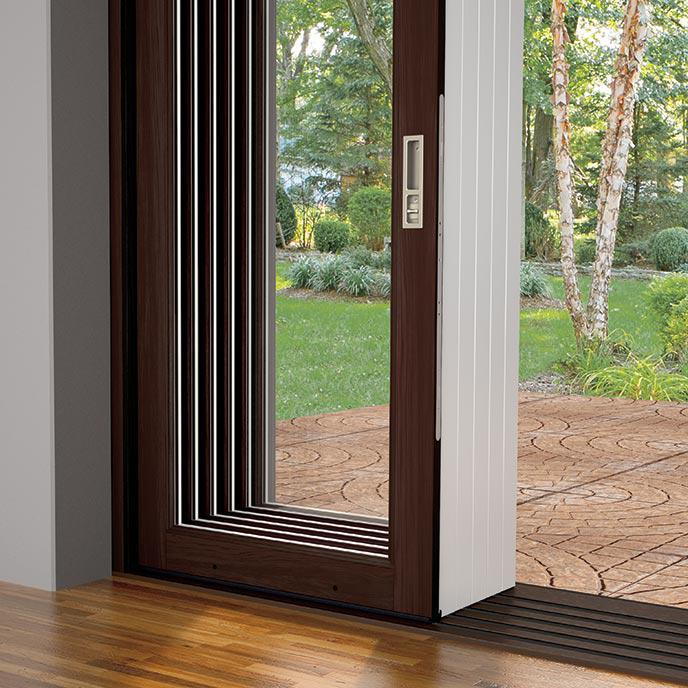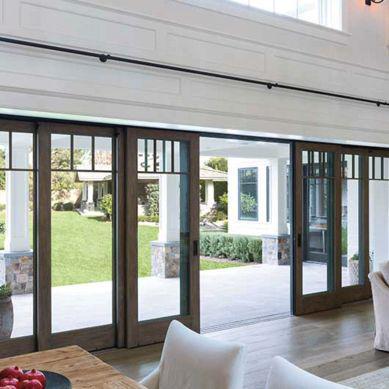The first image is the image on the left, the second image is the image on the right. For the images displayed, is the sentence "In at least one image there is an open white and glass panel door that shows chairs behind it." factually correct? Answer yes or no. No. The first image is the image on the left, the second image is the image on the right. Evaluate the accuracy of this statement regarding the images: "A set of doors opens to a dark colored table in the image ont he left.". Is it true? Answer yes or no. No. 